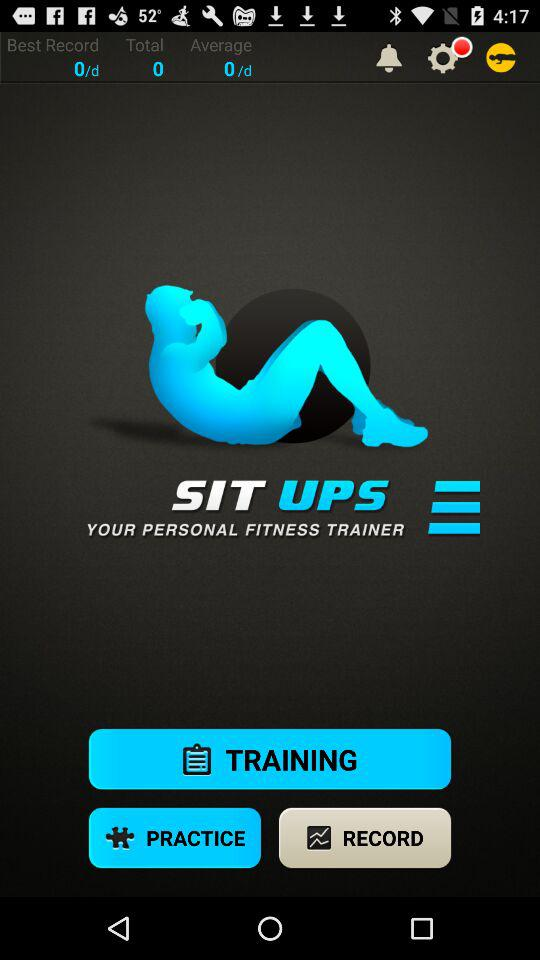What is the name of the application? The name of the application is "SIT UPS". 